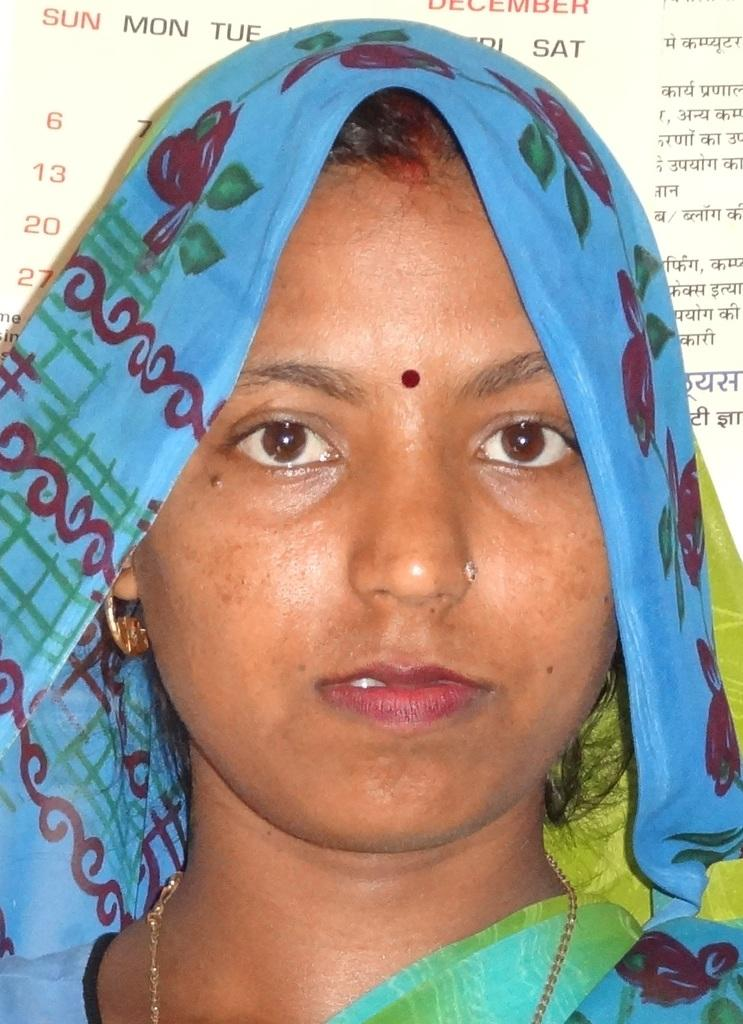What is the main subject of the image? The main subject of the image is a woman. What is the woman holding in the image? The woman is holding a paper with text and numbers on it in the image. What type of dress is the woman wearing in the image? The provided facts do not mention the woman's dress, so we cannot determine the type of dress she is wearing. 